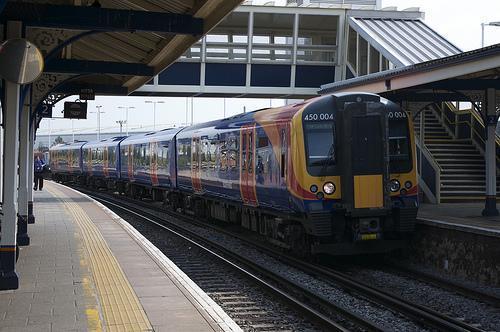How many people are in this photo?
Give a very brief answer. 1. How many train headlights are on?
Give a very brief answer. 1. How many sets of stairs are there in the photo?
Give a very brief answer. 1. How many train tracks are in the photo?
Give a very brief answer. 2. How many people are riding bicycles?
Give a very brief answer. 0. 